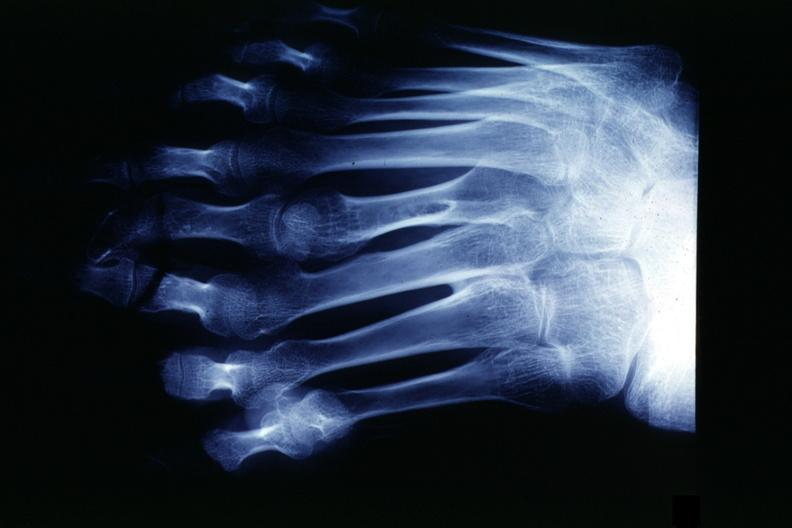what is present?
Answer the question using a single word or phrase. Supernumerary digits 